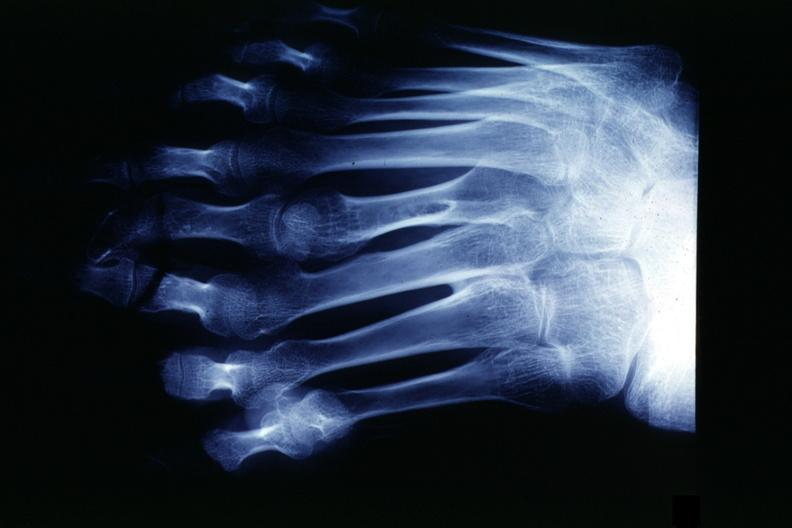what is present?
Answer the question using a single word or phrase. Supernumerary digits 